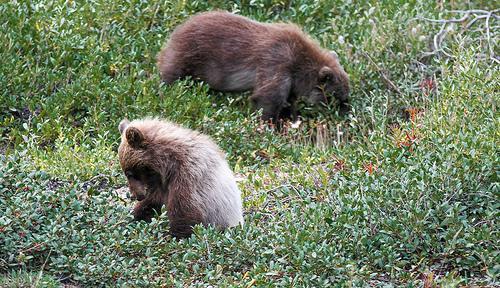How many bears are in the scene?
Give a very brief answer. 2. How many bears are in picture?
Give a very brief answer. 2. How many bears?
Give a very brief answer. 2. 